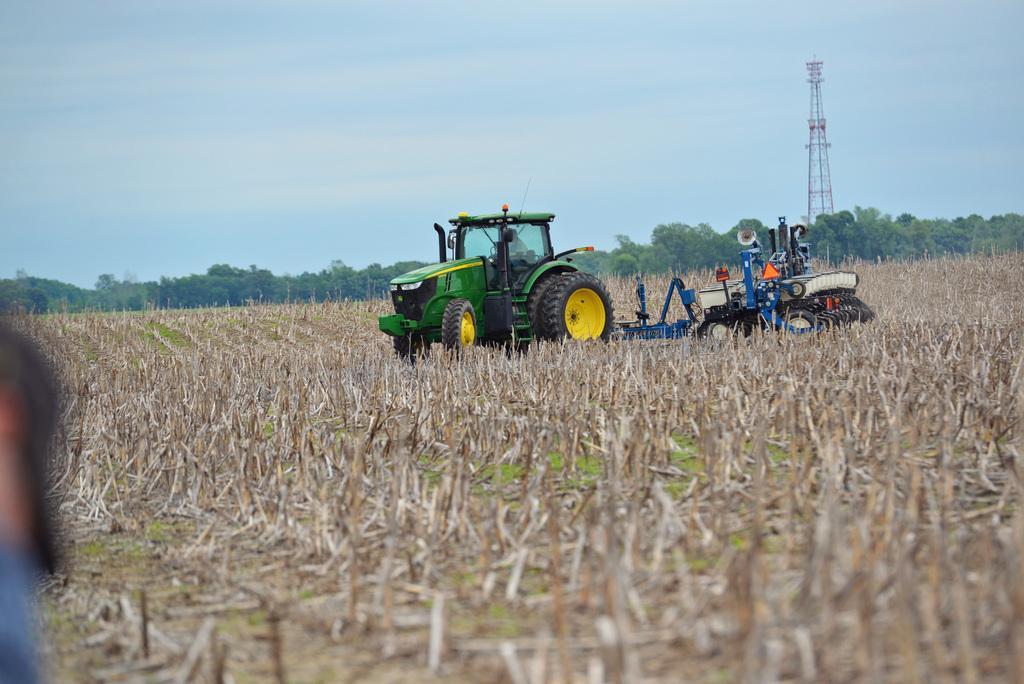How would you summarize this image in a sentence or two? In this image we can see a tractor and a bulldozer in the agricultural farm. In the background we can see sky with clouds, tower and trees. 